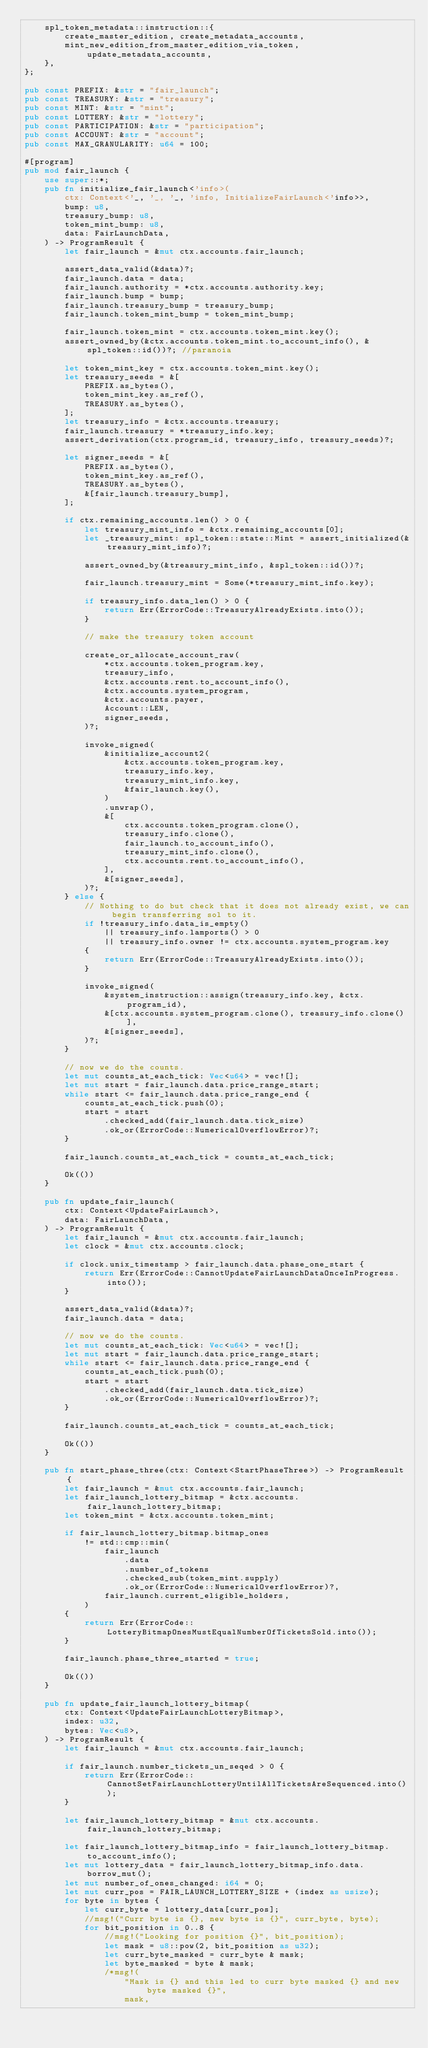Convert code to text. <code><loc_0><loc_0><loc_500><loc_500><_Rust_>    spl_token_metadata::instruction::{
        create_master_edition, create_metadata_accounts,
        mint_new_edition_from_master_edition_via_token, update_metadata_accounts,
    },
};

pub const PREFIX: &str = "fair_launch";
pub const TREASURY: &str = "treasury";
pub const MINT: &str = "mint";
pub const LOTTERY: &str = "lottery";
pub const PARTICIPATION: &str = "participation";
pub const ACCOUNT: &str = "account";
pub const MAX_GRANULARITY: u64 = 100;

#[program]
pub mod fair_launch {
    use super::*;
    pub fn initialize_fair_launch<'info>(
        ctx: Context<'_, '_, '_, 'info, InitializeFairLaunch<'info>>,
        bump: u8,
        treasury_bump: u8,
        token_mint_bump: u8,
        data: FairLaunchData,
    ) -> ProgramResult {
        let fair_launch = &mut ctx.accounts.fair_launch;

        assert_data_valid(&data)?;
        fair_launch.data = data;
        fair_launch.authority = *ctx.accounts.authority.key;
        fair_launch.bump = bump;
        fair_launch.treasury_bump = treasury_bump;
        fair_launch.token_mint_bump = token_mint_bump;

        fair_launch.token_mint = ctx.accounts.token_mint.key();
        assert_owned_by(&ctx.accounts.token_mint.to_account_info(), &spl_token::id())?; //paranoia

        let token_mint_key = ctx.accounts.token_mint.key();
        let treasury_seeds = &[
            PREFIX.as_bytes(),
            token_mint_key.as_ref(),
            TREASURY.as_bytes(),
        ];
        let treasury_info = &ctx.accounts.treasury;
        fair_launch.treasury = *treasury_info.key;
        assert_derivation(ctx.program_id, treasury_info, treasury_seeds)?;

        let signer_seeds = &[
            PREFIX.as_bytes(),
            token_mint_key.as_ref(),
            TREASURY.as_bytes(),
            &[fair_launch.treasury_bump],
        ];

        if ctx.remaining_accounts.len() > 0 {
            let treasury_mint_info = &ctx.remaining_accounts[0];
            let _treasury_mint: spl_token::state::Mint = assert_initialized(&treasury_mint_info)?;

            assert_owned_by(&treasury_mint_info, &spl_token::id())?;

            fair_launch.treasury_mint = Some(*treasury_mint_info.key);

            if treasury_info.data_len() > 0 {
                return Err(ErrorCode::TreasuryAlreadyExists.into());
            }

            // make the treasury token account

            create_or_allocate_account_raw(
                *ctx.accounts.token_program.key,
                treasury_info,
                &ctx.accounts.rent.to_account_info(),
                &ctx.accounts.system_program,
                &ctx.accounts.payer,
                Account::LEN,
                signer_seeds,
            )?;

            invoke_signed(
                &initialize_account2(
                    &ctx.accounts.token_program.key,
                    treasury_info.key,
                    treasury_mint_info.key,
                    &fair_launch.key(),
                )
                .unwrap(),
                &[
                    ctx.accounts.token_program.clone(),
                    treasury_info.clone(),
                    fair_launch.to_account_info(),
                    treasury_mint_info.clone(),
                    ctx.accounts.rent.to_account_info(),
                ],
                &[signer_seeds],
            )?;
        } else {
            // Nothing to do but check that it does not already exist, we can begin transferring sol to it.
            if !treasury_info.data_is_empty()
                || treasury_info.lamports() > 0
                || treasury_info.owner != ctx.accounts.system_program.key
            {
                return Err(ErrorCode::TreasuryAlreadyExists.into());
            }

            invoke_signed(
                &system_instruction::assign(treasury_info.key, &ctx.program_id),
                &[ctx.accounts.system_program.clone(), treasury_info.clone()],
                &[signer_seeds],
            )?;
        }

        // now we do the counts.
        let mut counts_at_each_tick: Vec<u64> = vec![];
        let mut start = fair_launch.data.price_range_start;
        while start <= fair_launch.data.price_range_end {
            counts_at_each_tick.push(0);
            start = start
                .checked_add(fair_launch.data.tick_size)
                .ok_or(ErrorCode::NumericalOverflowError)?;
        }

        fair_launch.counts_at_each_tick = counts_at_each_tick;

        Ok(())
    }

    pub fn update_fair_launch(
        ctx: Context<UpdateFairLaunch>,
        data: FairLaunchData,
    ) -> ProgramResult {
        let fair_launch = &mut ctx.accounts.fair_launch;
        let clock = &mut ctx.accounts.clock;

        if clock.unix_timestamp > fair_launch.data.phase_one_start {
            return Err(ErrorCode::CannotUpdateFairLaunchDataOnceInProgress.into());
        }

        assert_data_valid(&data)?;
        fair_launch.data = data;

        // now we do the counts.
        let mut counts_at_each_tick: Vec<u64> = vec![];
        let mut start = fair_launch.data.price_range_start;
        while start <= fair_launch.data.price_range_end {
            counts_at_each_tick.push(0);
            start = start
                .checked_add(fair_launch.data.tick_size)
                .ok_or(ErrorCode::NumericalOverflowError)?;
        }

        fair_launch.counts_at_each_tick = counts_at_each_tick;

        Ok(())
    }

    pub fn start_phase_three(ctx: Context<StartPhaseThree>) -> ProgramResult {
        let fair_launch = &mut ctx.accounts.fair_launch;
        let fair_launch_lottery_bitmap = &ctx.accounts.fair_launch_lottery_bitmap;
        let token_mint = &ctx.accounts.token_mint;

        if fair_launch_lottery_bitmap.bitmap_ones
            != std::cmp::min(
                fair_launch
                    .data
                    .number_of_tokens
                    .checked_sub(token_mint.supply)
                    .ok_or(ErrorCode::NumericalOverflowError)?,
                fair_launch.current_eligible_holders,
            )
        {
            return Err(ErrorCode::LotteryBitmapOnesMustEqualNumberOfTicketsSold.into());
        }

        fair_launch.phase_three_started = true;

        Ok(())
    }

    pub fn update_fair_launch_lottery_bitmap(
        ctx: Context<UpdateFairLaunchLotteryBitmap>,
        index: u32,
        bytes: Vec<u8>,
    ) -> ProgramResult {
        let fair_launch = &mut ctx.accounts.fair_launch;

        if fair_launch.number_tickets_un_seqed > 0 {
            return Err(ErrorCode::CannotSetFairLaunchLotteryUntilAllTicketsAreSequenced.into());
        }

        let fair_launch_lottery_bitmap = &mut ctx.accounts.fair_launch_lottery_bitmap;

        let fair_launch_lottery_bitmap_info = fair_launch_lottery_bitmap.to_account_info();
        let mut lottery_data = fair_launch_lottery_bitmap_info.data.borrow_mut();
        let mut number_of_ones_changed: i64 = 0;
        let mut curr_pos = FAIR_LAUNCH_LOTTERY_SIZE + (index as usize);
        for byte in bytes {
            let curr_byte = lottery_data[curr_pos];
            //msg!("Curr byte is {}, new byte is {}", curr_byte, byte);
            for bit_position in 0..8 {
                //msg!("Looking for position {}", bit_position);
                let mask = u8::pow(2, bit_position as u32);
                let curr_byte_masked = curr_byte & mask;
                let byte_masked = byte & mask;
                /*msg!(
                    "Mask is {} and this led to curr byte masked {} and new byte masked {}",
                    mask,</code> 